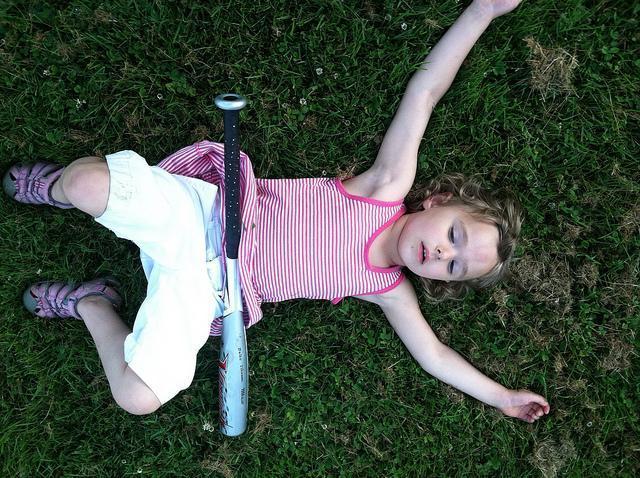How many people are there?
Give a very brief answer. 1. 